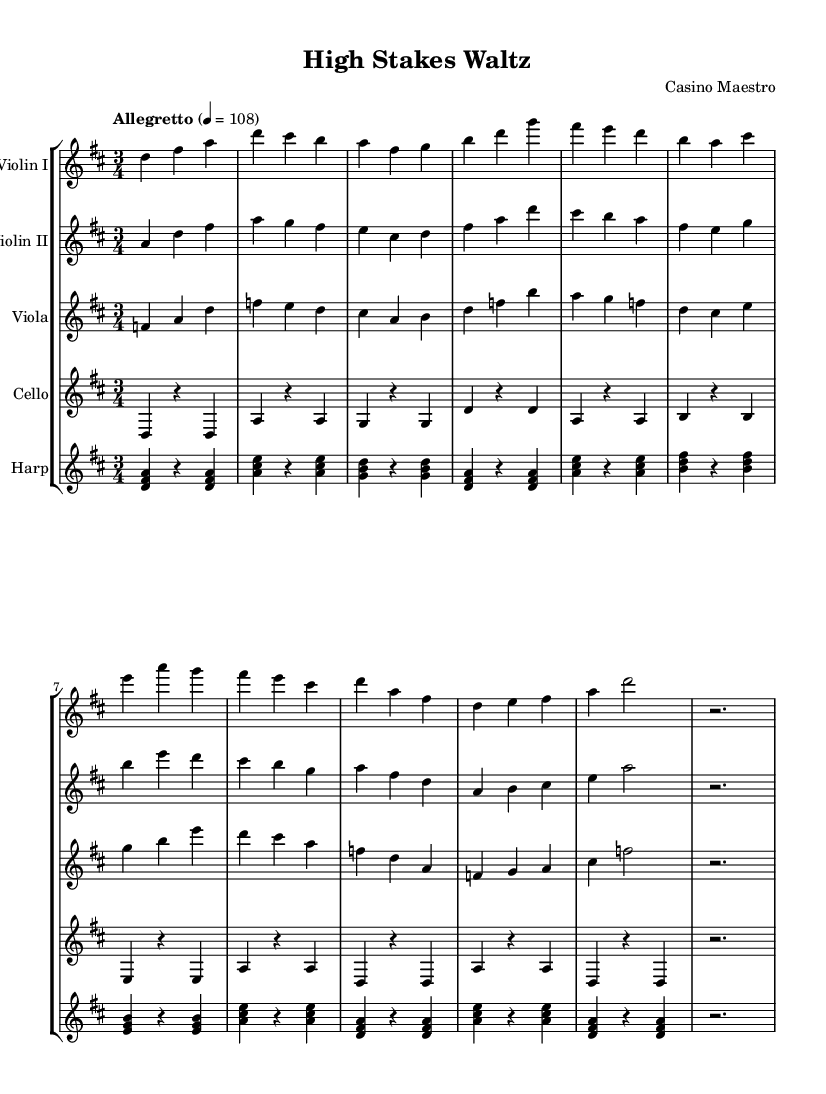What is the key signature of this music? The key signature is D major, which has two sharps: F# and C#.
Answer: D major What is the time signature of this piece? The time signature is 3/4, indicating three beats per measure and a quarter note receives one beat.
Answer: 3/4 What is the tempo marking given for this piece? The tempo marking is "Allegretto," which is typically moderately fast, and the metronome marking is set at 108 beats per minute.
Answer: Allegretto What is the last note played by the Violin I? The last note for Violin I is a rest for two beats, indicated by r2 at the end of the staff.
Answer: r2 How many measures are in the Violin II part? Violin II part has eleven measures in total, as indicated by the various note patterns and the absence of additional measures.
Answer: 11 In which year was this piece likely composed, based on the style? Given the elegant and sophisticated orchestral sound typical of luxurious environments, this piece was likely crafted in the early 20th century.
Answer: Early 20th century Which instrument plays the harmonic framework most prominently? The harp plays the harmonic framework predominantly, providing rich arpeggios that support the orchestration throughout the piece.
Answer: Harp 